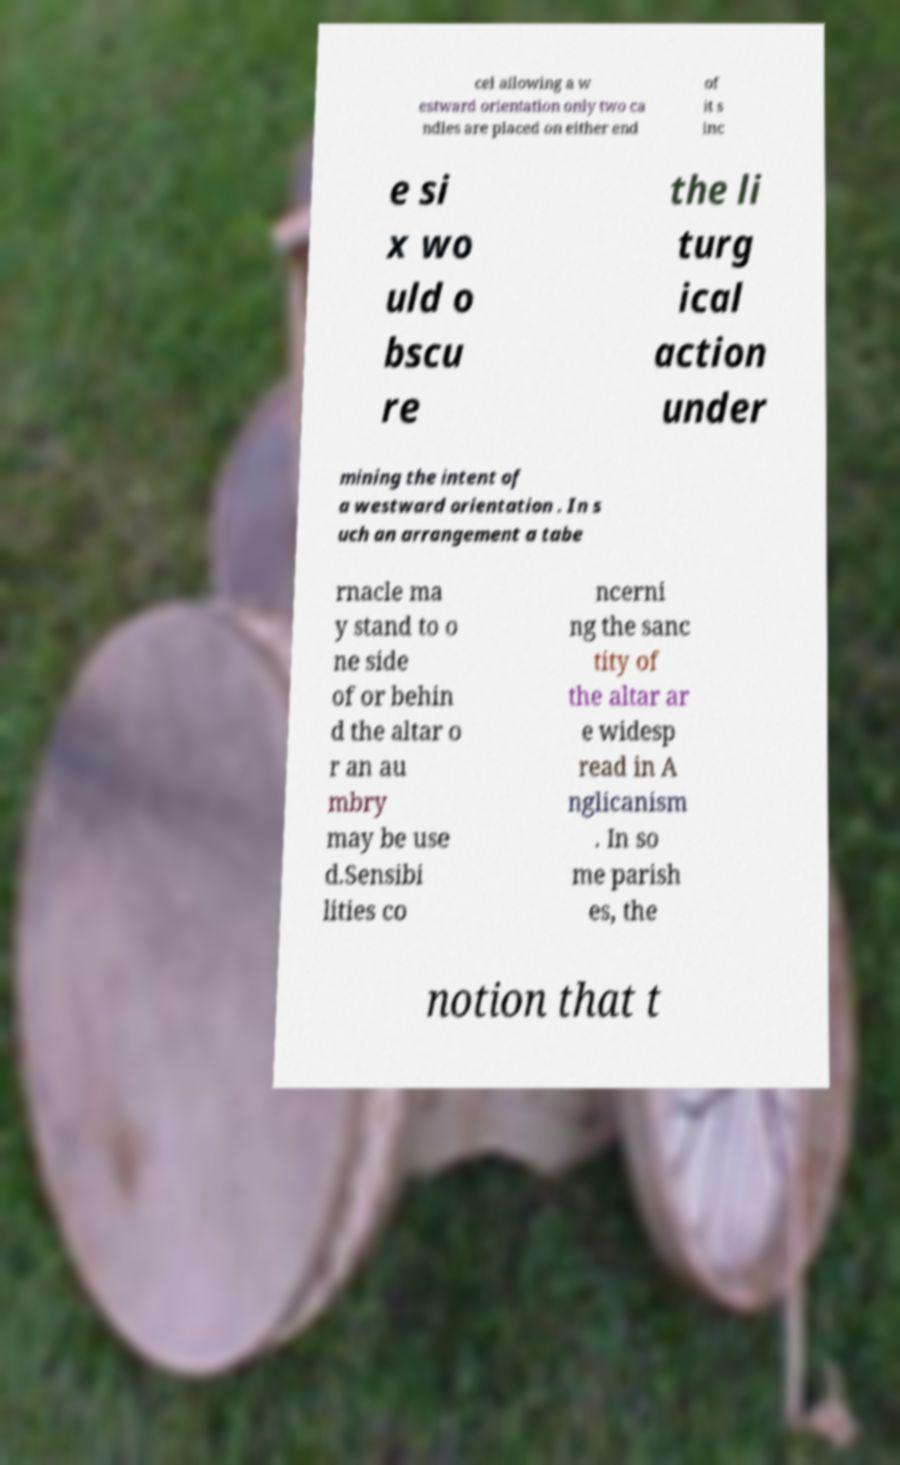Please read and relay the text visible in this image. What does it say? cel allowing a w estward orientation only two ca ndles are placed on either end of it s inc e si x wo uld o bscu re the li turg ical action under mining the intent of a westward orientation . In s uch an arrangement a tabe rnacle ma y stand to o ne side of or behin d the altar o r an au mbry may be use d.Sensibi lities co ncerni ng the sanc tity of the altar ar e widesp read in A nglicanism . In so me parish es, the notion that t 